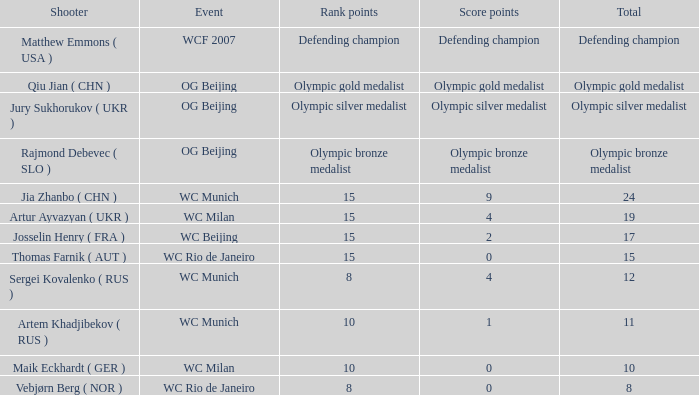Who was the shooter for the WC Beijing event? Josselin Henry ( FRA ). 